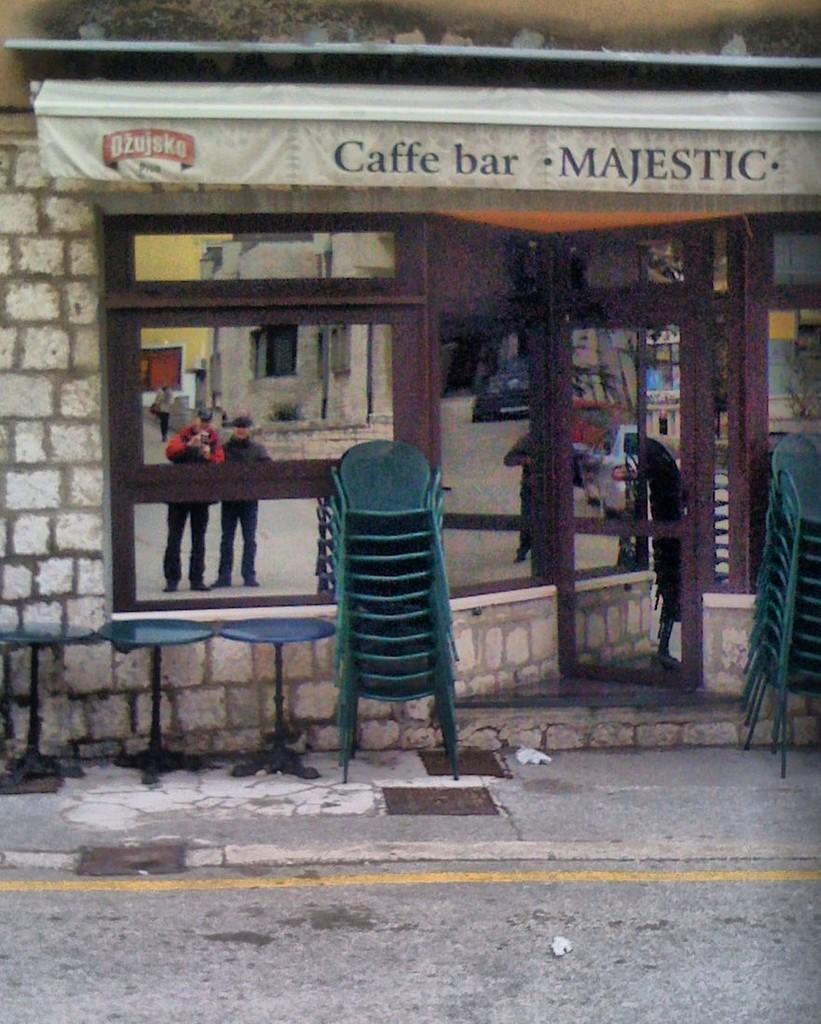Could you give a brief overview of what you see in this image? In this image we can see chairs, reflection of persons in the mirror, and a wall. 